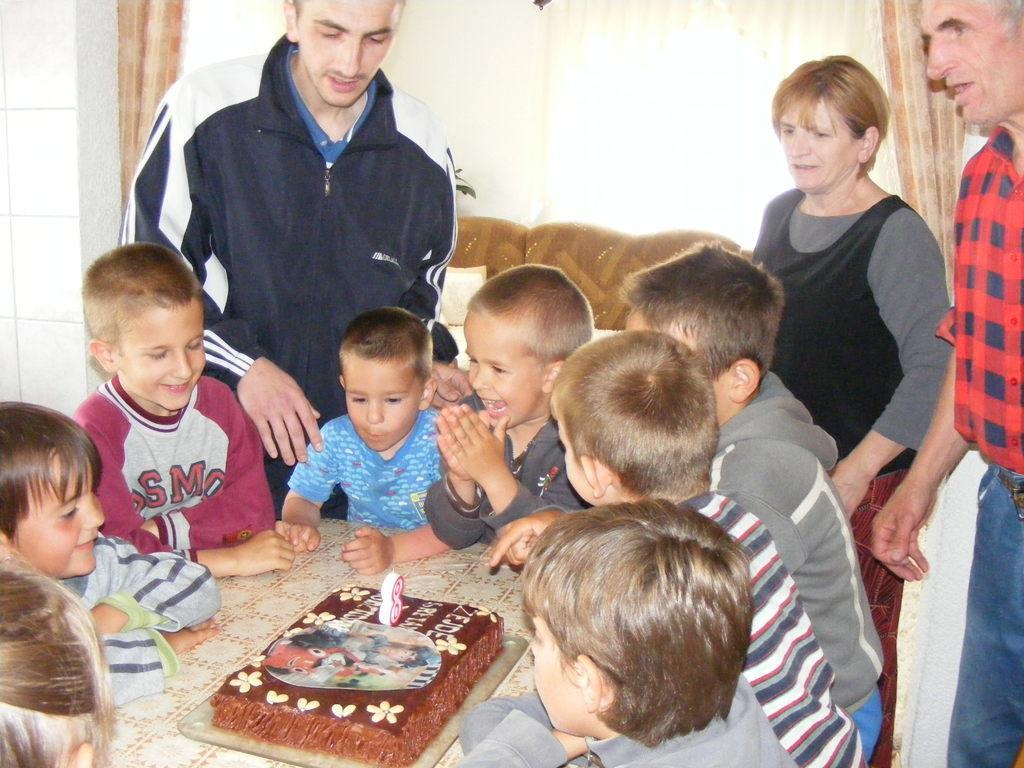Describe this image in one or two sentences. In this picture we can see few children are sitting around the table, and this is the cake. Here we can see three persons standing on the floor. And this is the wall. 